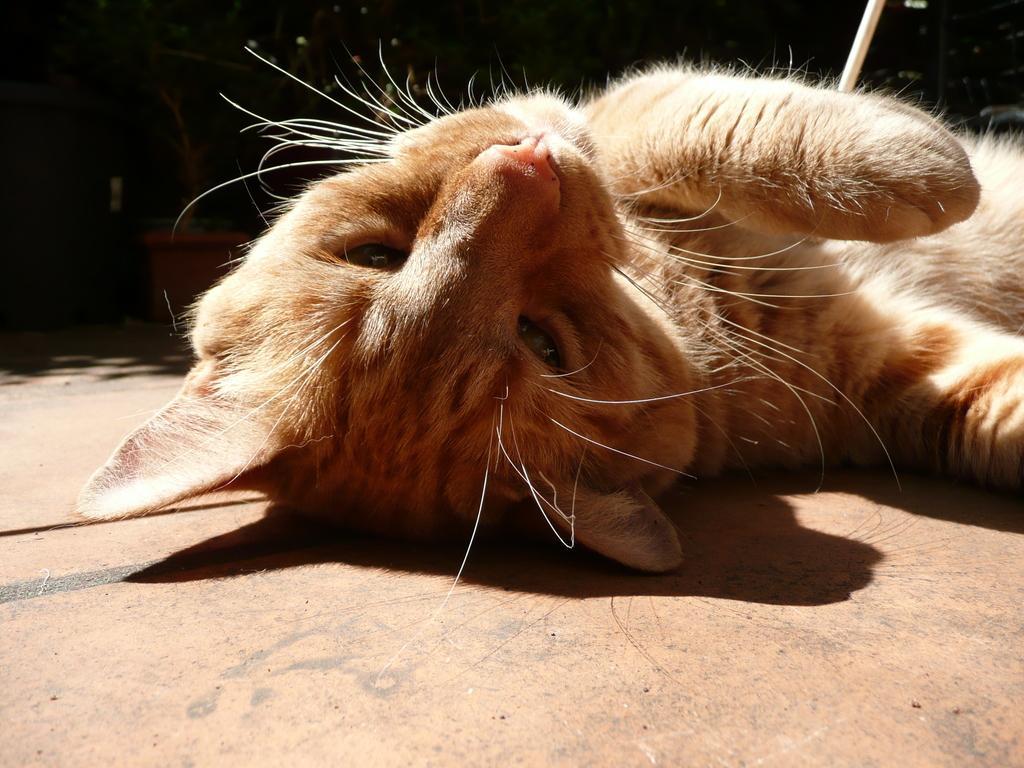Please provide a concise description of this image. In the picture I can see a cat is lying on the floor. The background of the image is dark. 